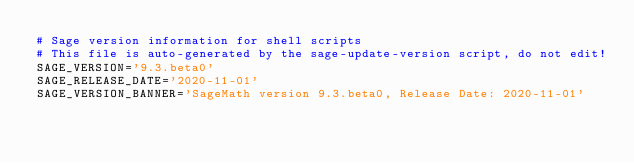Convert code to text. <code><loc_0><loc_0><loc_500><loc_500><_Bash_># Sage version information for shell scripts
# This file is auto-generated by the sage-update-version script, do not edit!
SAGE_VERSION='9.3.beta0'
SAGE_RELEASE_DATE='2020-11-01'
SAGE_VERSION_BANNER='SageMath version 9.3.beta0, Release Date: 2020-11-01'
</code> 